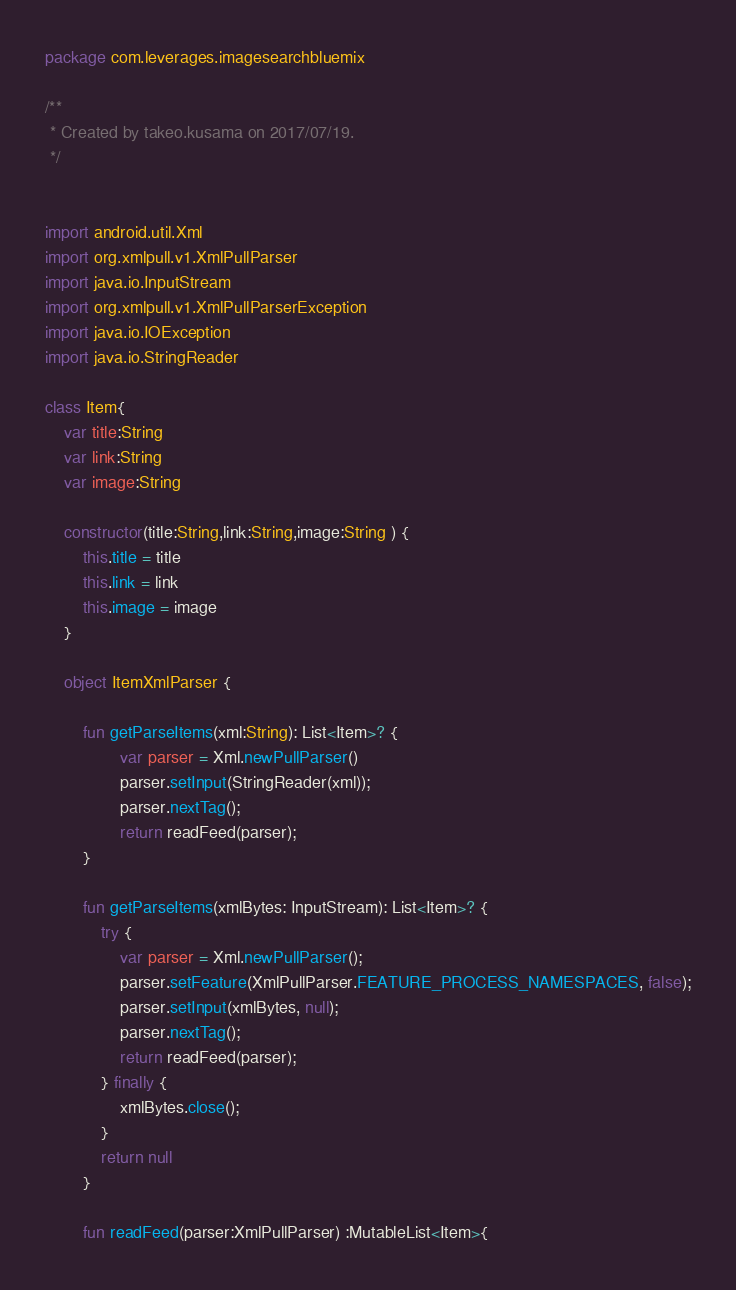Convert code to text. <code><loc_0><loc_0><loc_500><loc_500><_Kotlin_>package com.leverages.imagesearchbluemix

/**
 * Created by takeo.kusama on 2017/07/19.
 */


import android.util.Xml
import org.xmlpull.v1.XmlPullParser
import java.io.InputStream
import org.xmlpull.v1.XmlPullParserException
import java.io.IOException
import java.io.StringReader

class Item{
    var title:String
    var link:String
    var image:String

    constructor(title:String,link:String,image:String ) {
        this.title = title
        this.link = link
        this.image = image
    }

    object ItemXmlParser {

        fun getParseItems(xml:String): List<Item>? {
                var parser = Xml.newPullParser()
                parser.setInput(StringReader(xml));
                parser.nextTag();
                return readFeed(parser);
        }

        fun getParseItems(xmlBytes: InputStream): List<Item>? {
            try {
                var parser = Xml.newPullParser();
                parser.setFeature(XmlPullParser.FEATURE_PROCESS_NAMESPACES, false);
                parser.setInput(xmlBytes, null);
                parser.nextTag();
                return readFeed(parser);
            } finally {
                xmlBytes.close();
            }
            return null
        }

        fun readFeed(parser:XmlPullParser) :MutableList<Item>{</code> 